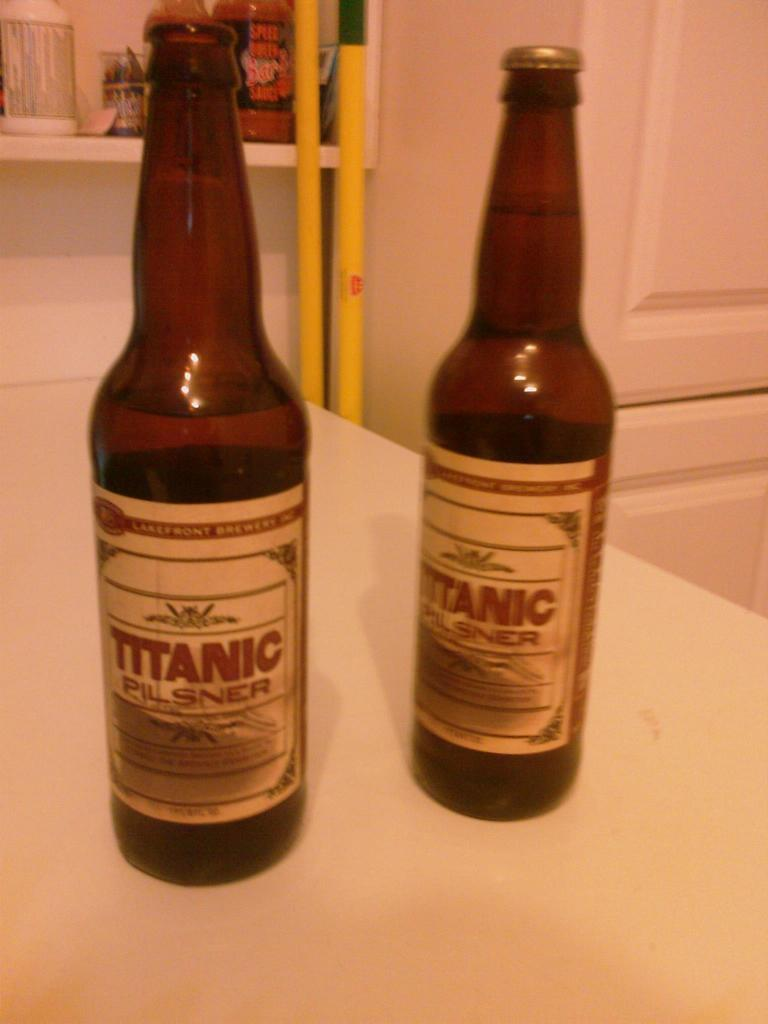<image>
Write a terse but informative summary of the picture. Two bottles of Titanic brand beer stand upright on a pale table. 